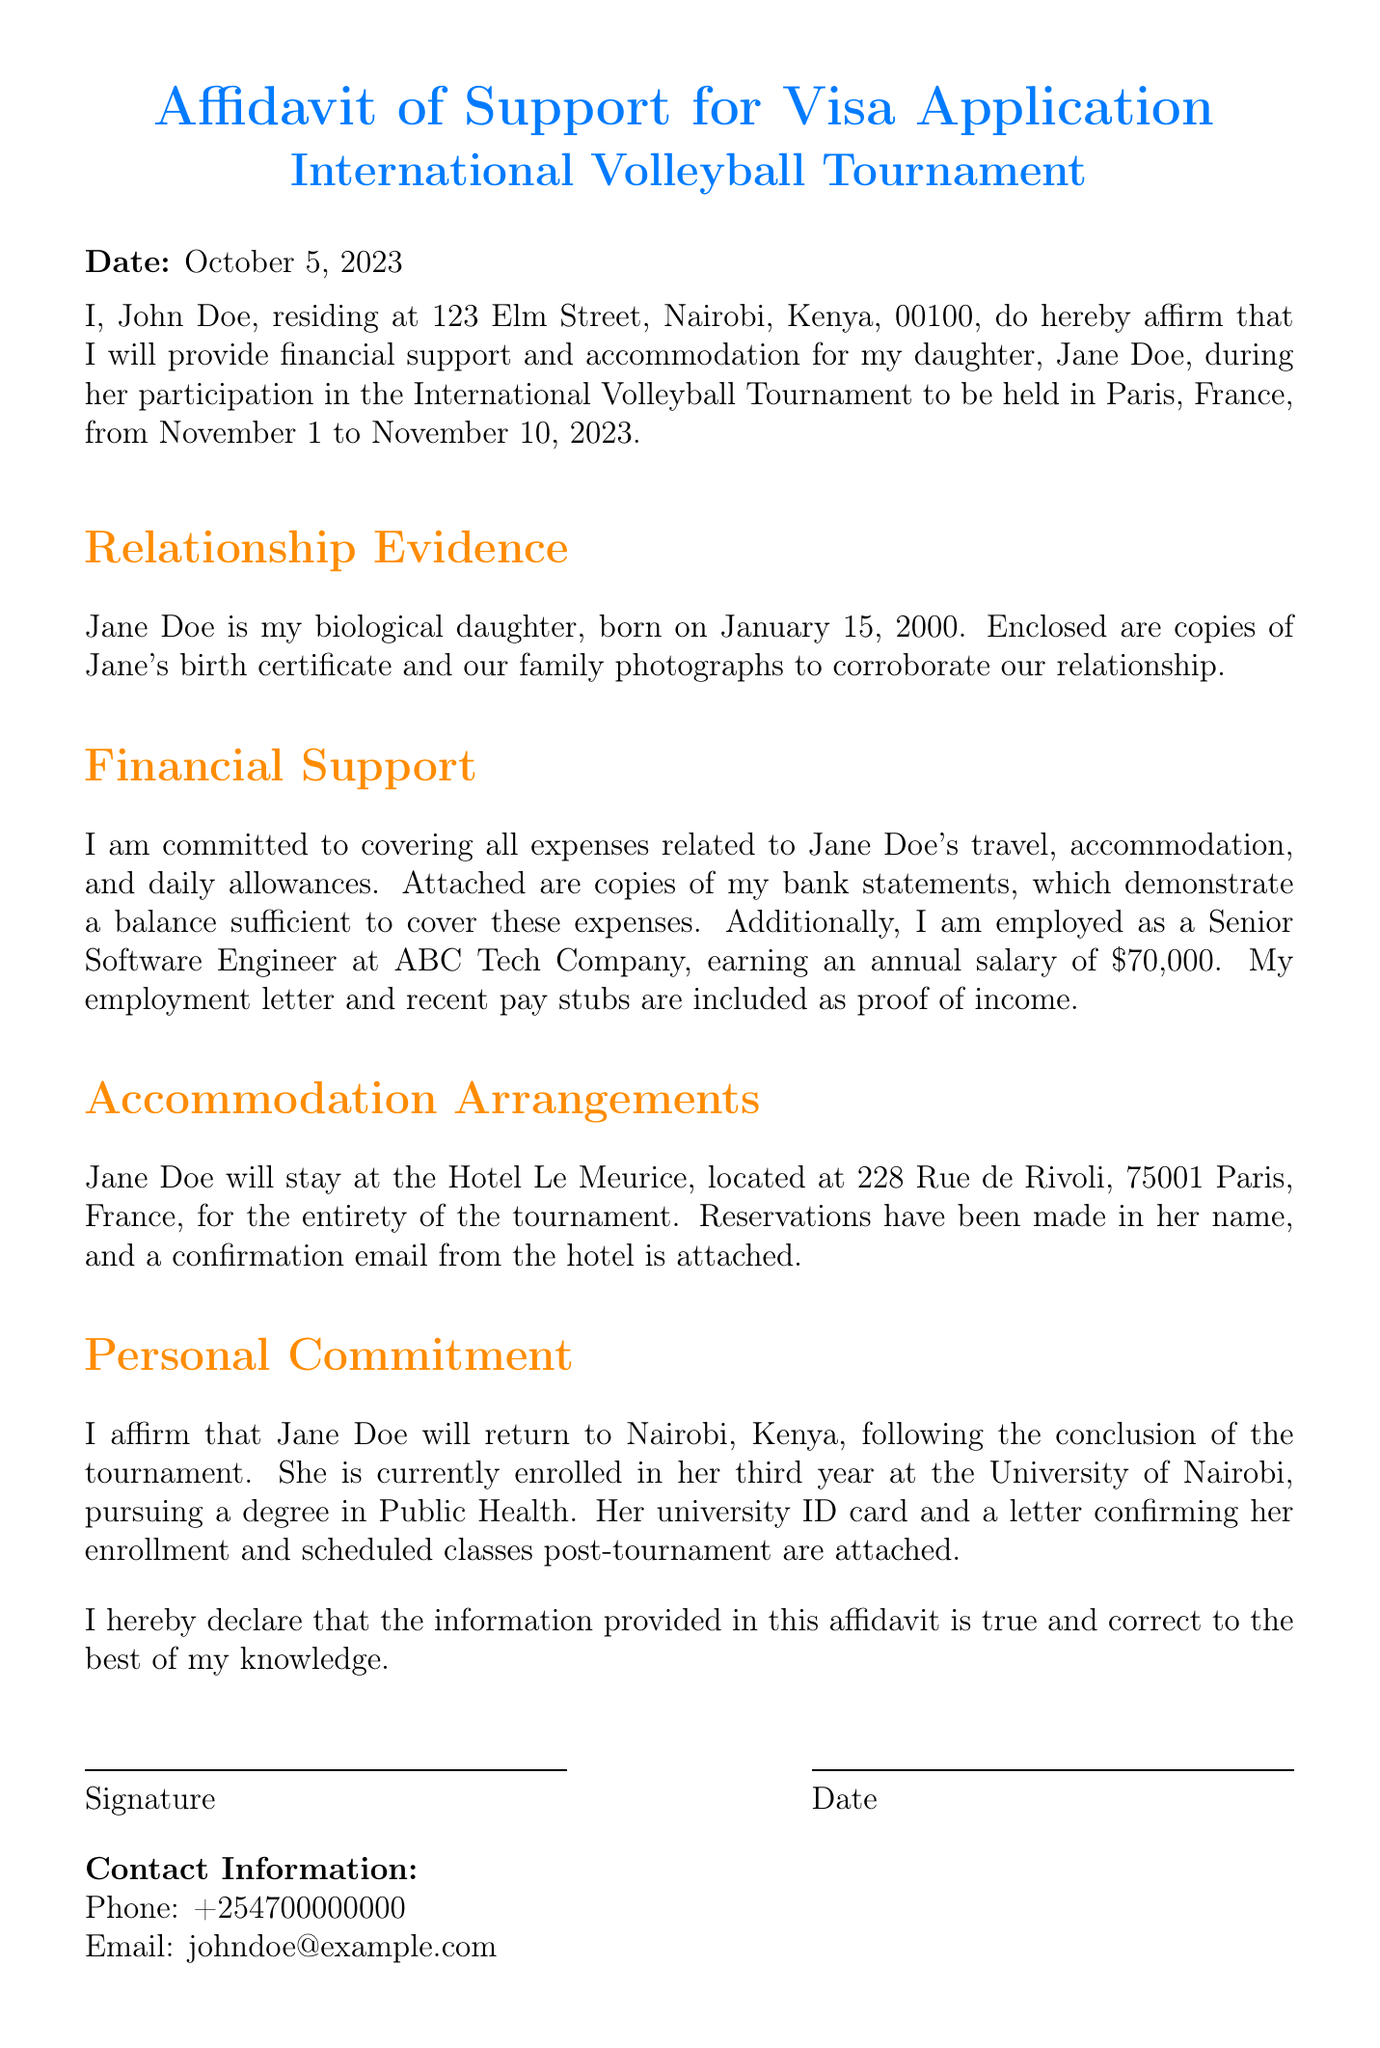What is the name of the person providing financial support? The name of the person providing financial support is John Doe.
Answer: John Doe What is the relationship between John Doe and Jane Doe? The document states that Jane Doe is John Doe's biological daughter.
Answer: Biological daughter What are the dates of the International Volleyball Tournament? The tournament is scheduled to take place from November 1 to November 10, 2023.
Answer: November 1 to November 10, 2023 What is the annual salary of John Doe? The annual salary mentioned in the affidavit is $70,000.
Answer: $70,000 Where will Jane Doe be staying during the tournament? Jane Doe will stay at Hotel Le Meurice.
Answer: Hotel Le Meurice What document is attached to prove Jane's enrollment at the University? The document attached to prove Jane's enrollment is her university ID card.
Answer: University ID card What is the address of Hotel Le Meurice? The address of Hotel Le Meurice is 228 Rue de Rivoli, 75001 Paris, France.
Answer: 228 Rue de Rivoli, 75001 Paris, France What is Jane Doe’s date of birth? Jane Doe was born on January 15, 2000.
Answer: January 15, 2000 What is the purpose of this affidavit? The purpose of the affidavit is to affirm financial support and accommodation for Jane Doe's visa application.
Answer: Visa application What is John Doe's occupation? John Doe's occupation is a Senior Software Engineer.
Answer: Senior Software Engineer 